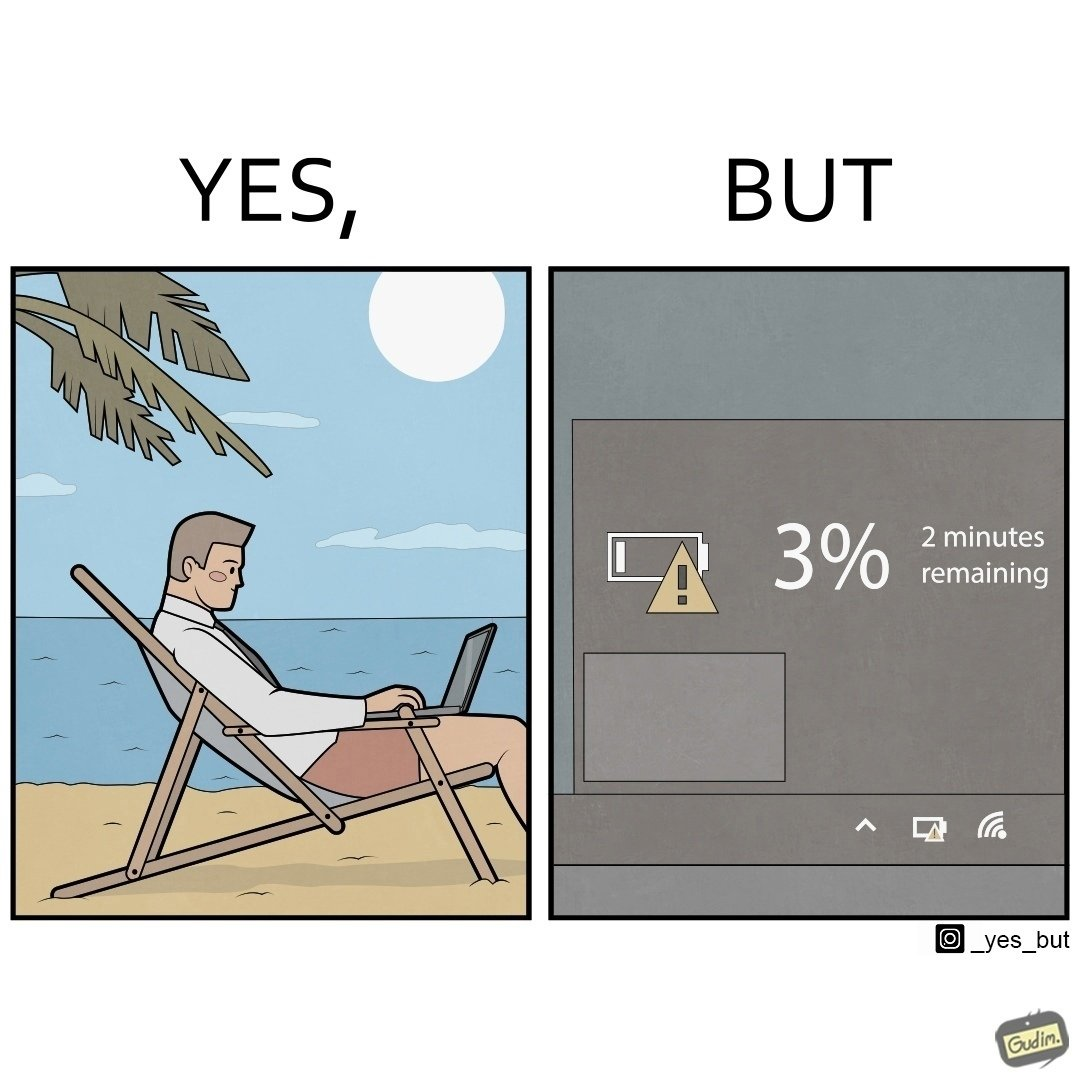Is this image satirical or non-satirical? Yes, this image is satirical. 